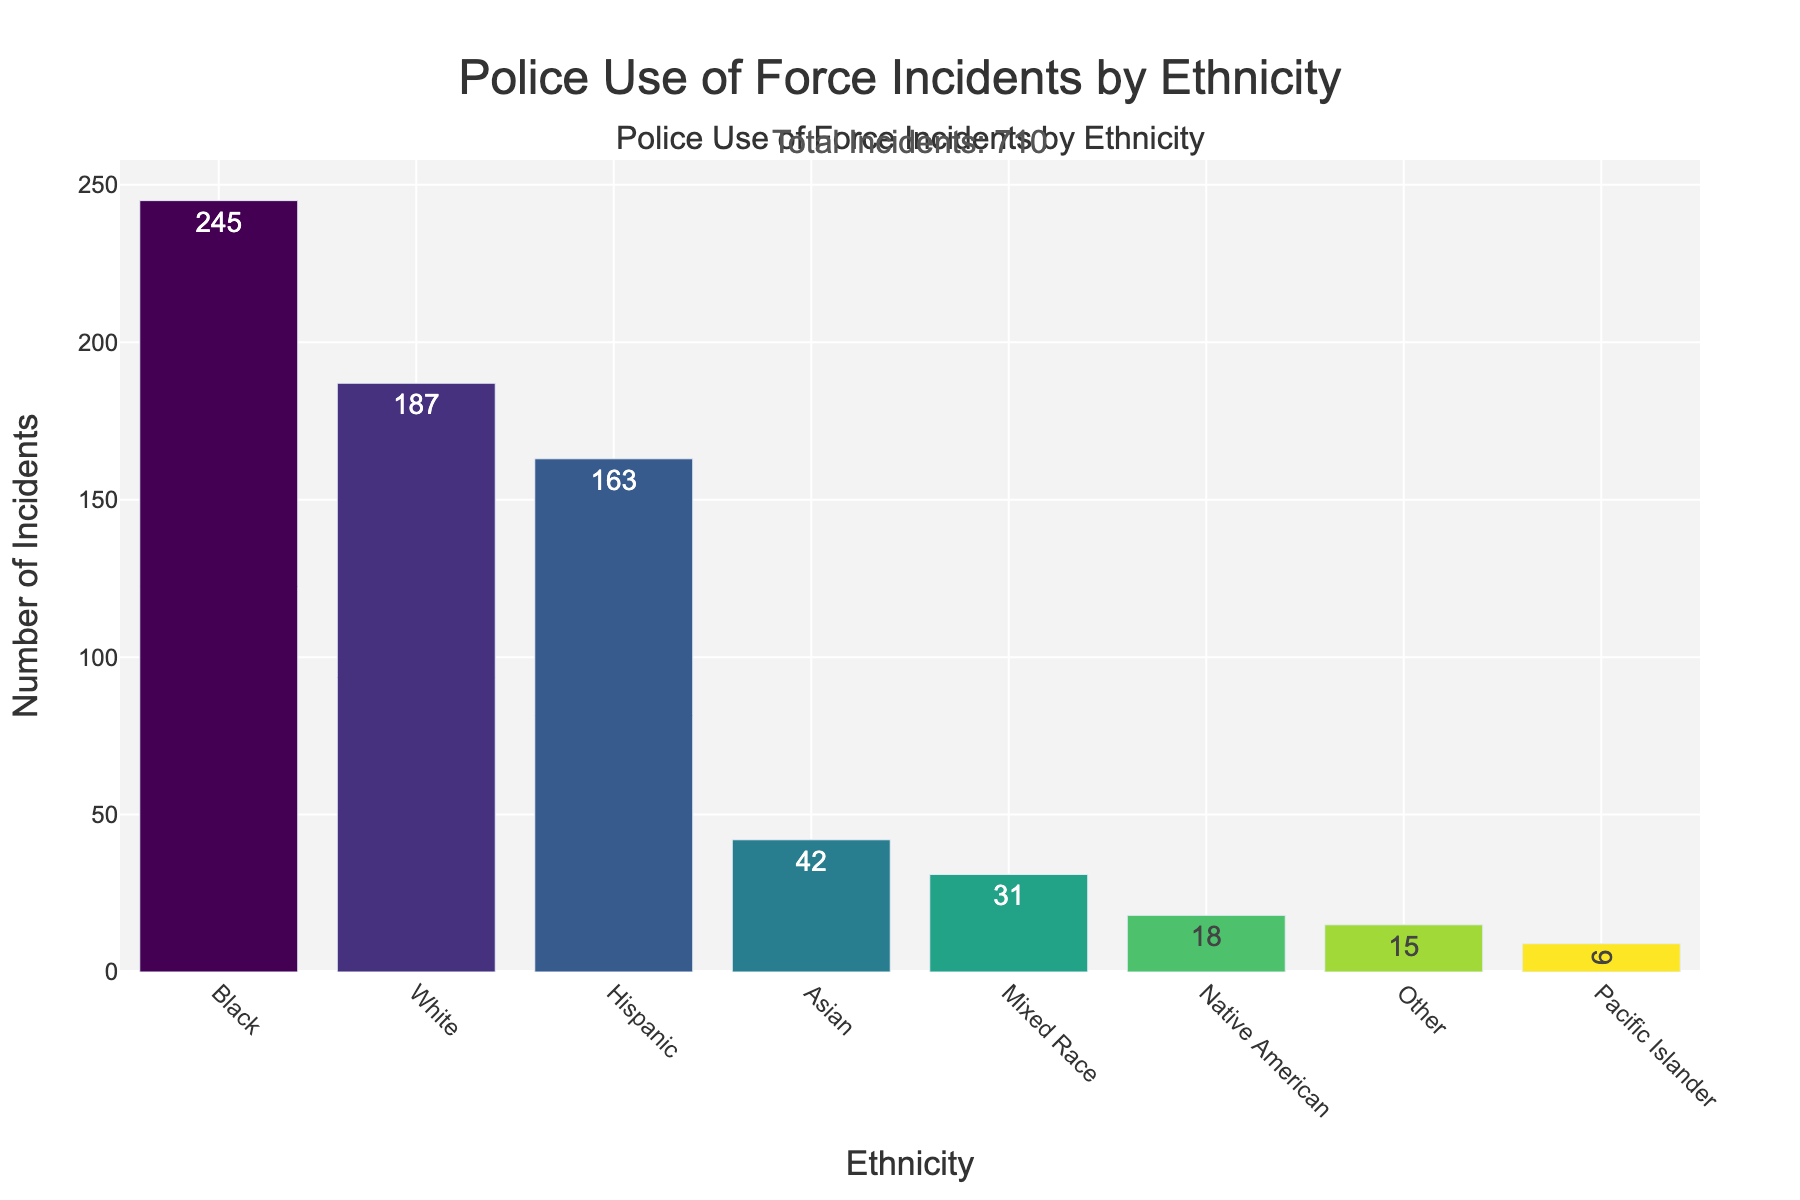Which ethnicity has the highest number of police use of force incidents? The ethnicity with the highest number of police use of force incidents is represented by the tallest bar in the chart. According to the data, Black has the highest number with 245 incidents.
Answer: Black Which ethnicity has the lowest number of police use of force incidents? The ethnicity with the lowest number of police use of force incidents is represented by the shortest bar in the chart. According to the data, Pacific Islander has the lowest number with 9 incidents.
Answer: Pacific Islander What is the total number of police use of force incidents? The total number of police use of force incidents can be found as an annotation in the figure. The text indicates "Total Incidents: 710," so the sum of incidents is 710.
Answer: 710 How many more incidents did Black individuals experience compared to Hispanic individuals? To find the difference in incidents between Black and Hispanic individuals, subtract the number of incidents for Hispanic (163) from the number for Black (245). The difference is 245 - 163.
Answer: 82 What is the combined number of incidents for Native American and Mixed Race individuals? To find the combined number, add the incidents for Native American (18) and Mixed Race (31). The sum is 18 + 31.
Answer: 49 Which two ethnicities have the closest number of incidents, and what are their respective numbers? By comparing the numbers, we see that Native American (18) and Other (15) have numbers that are close to each other.
Answer: Native American (18) and Other (15) What is the average number of incidents across all ethnicities? To find the average, sum all incidents (which is 710) and divide by the number of ethnicities (8). The average is 710 / 8.
Answer: 88.75 How many ethnicities experienced fewer than 50 incidents? By counting the bars with the height representing fewer than 50 incidents: Asian (42), Native American (18), Pacific Islander (9), Mixed Race (31), and Other (15). There are 5 ethnicities.
Answer: 5 Among the ethnicities with more than 100 incidents, which one had the least incidents, and how many? Ethnicities with more than 100 incidents include White (187), Black (245), and Hispanic (163). Of these, Hispanic had the least with 163.
Answer: Hispanic (163) Which ethnicity had approximately double the number of incidents compared to Asian individuals? Asian individuals experienced 42 incidents. Approximately double this number is 42 * 2 = 84. Hispanic individuals experienced 163 incidents, which is close to double the number of Asian incidents.
Answer: Hispanic 